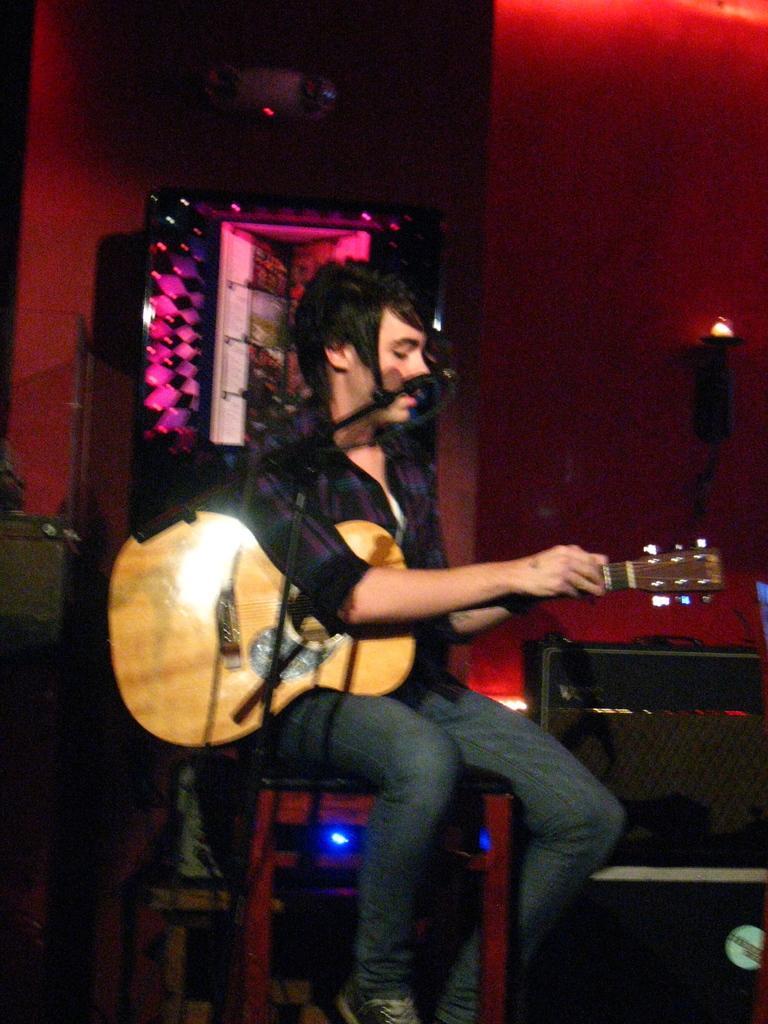Can you describe this image briefly? As we can see in the image there is a man sitting on chair and holding guitar. In front of him there is a mic. 